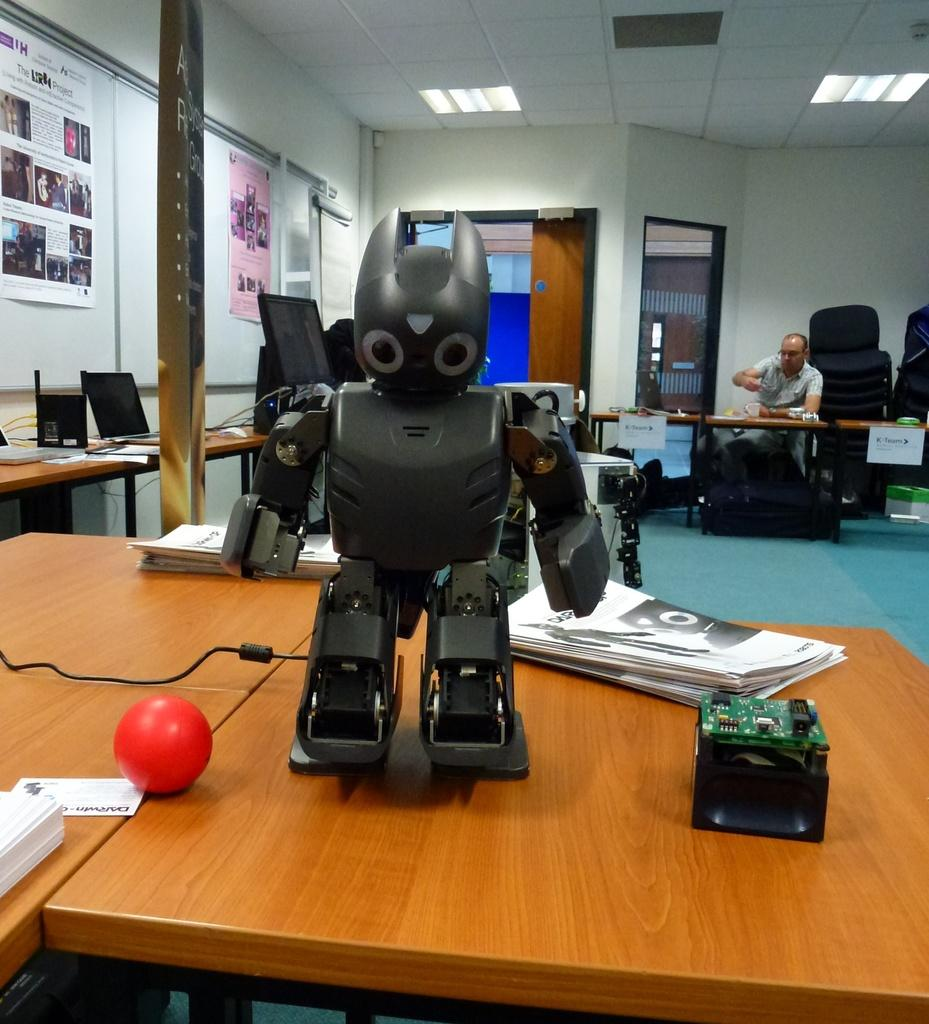What is the main subject in the image? There is a robot in the image. What objects can be seen on the table in the image? There are papers on the table. Can you describe the background of the image? There is a person in the background of the image. Where are additional papers located in the image? There are papers attached to the wall on the left side of the image. What type of tin can be seen in the image? There is no tin present in the image. What thrilling activity is the robot performing in the image? The image does not depict any specific activity being performed by the robot, so it cannot be determined if it is thrilling or not. 